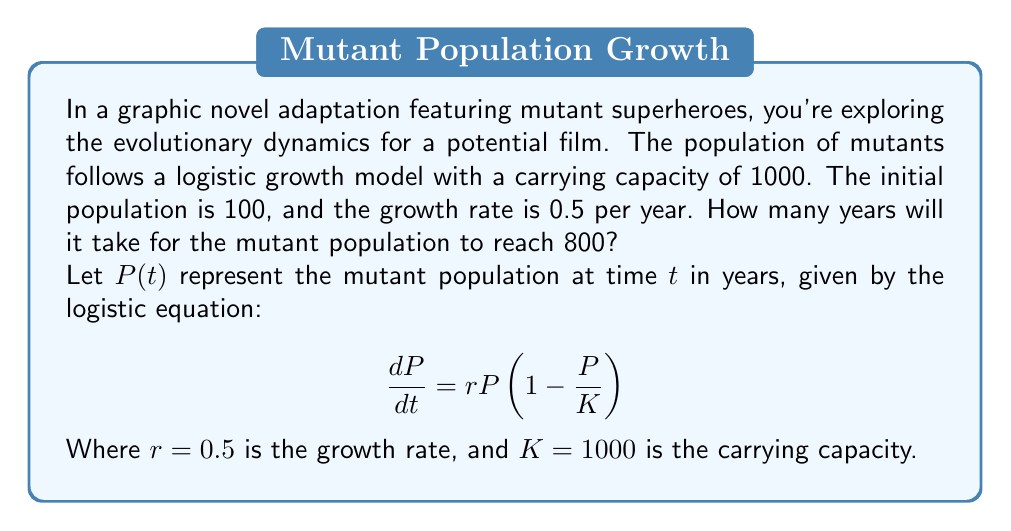Could you help me with this problem? To solve this problem, we'll use the analytical solution of the logistic growth equation:

$$P(t) = \frac{KP_0}{P_0 + (K-P_0)e^{-rt}}$$

Where $P_0$ is the initial population, $K$ is the carrying capacity, $r$ is the growth rate, and $t$ is time.

Given:
$P_0 = 100$
$K = 1000$
$r = 0.5$
$P(t) = 800$ (the target population)

Step 1: Substitute the values into the equation and solve for $t$:

$$800 = \frac{1000 \cdot 100}{100 + (1000-100)e^{-0.5t}}$$

Step 2: Simplify:

$$800 = \frac{100000}{100 + 900e^{-0.5t}}$$

Step 3: Multiply both sides by the denominator:

$$80000 + 720000e^{-0.5t} = 100000$$

Step 4: Subtract 80000 from both sides:

$$720000e^{-0.5t} = 20000$$

Step 5: Divide both sides by 720000:

$$e^{-0.5t} = \frac{1}{36}$$

Step 6: Take the natural logarithm of both sides:

$$-0.5t = \ln(\frac{1}{36})$$

Step 7: Solve for $t$:

$$t = -\frac{2\ln(\frac{1}{36})}{0.5} = -2\ln(\frac{1}{36}) = 2\ln(36)$$

Step 8: Calculate the final result:

$$t \approx 7.18$$

Therefore, it will take approximately 7.18 years for the mutant population to reach 800.
Answer: 7.18 years 